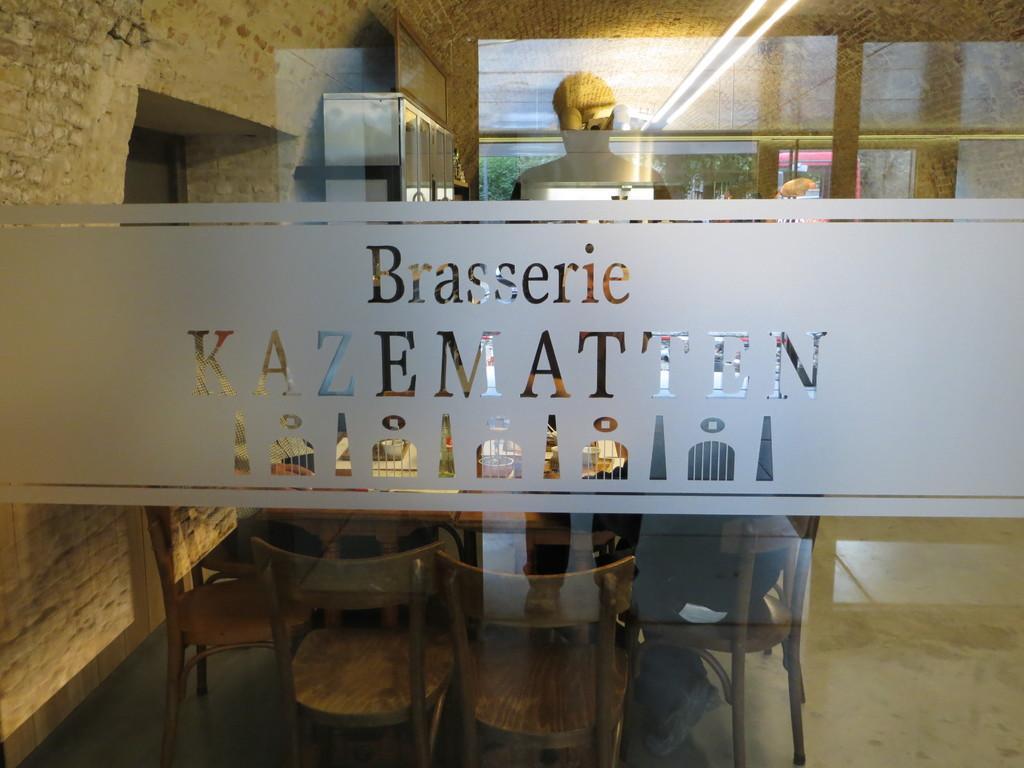Can you describe this image briefly? In the picture we can see a glass wall with a name on it as BRASSAIRE KAZAMATTEN, behind the wall we can see a rack and some chairs and person sitting on it and to the ceiling we can see a light. 